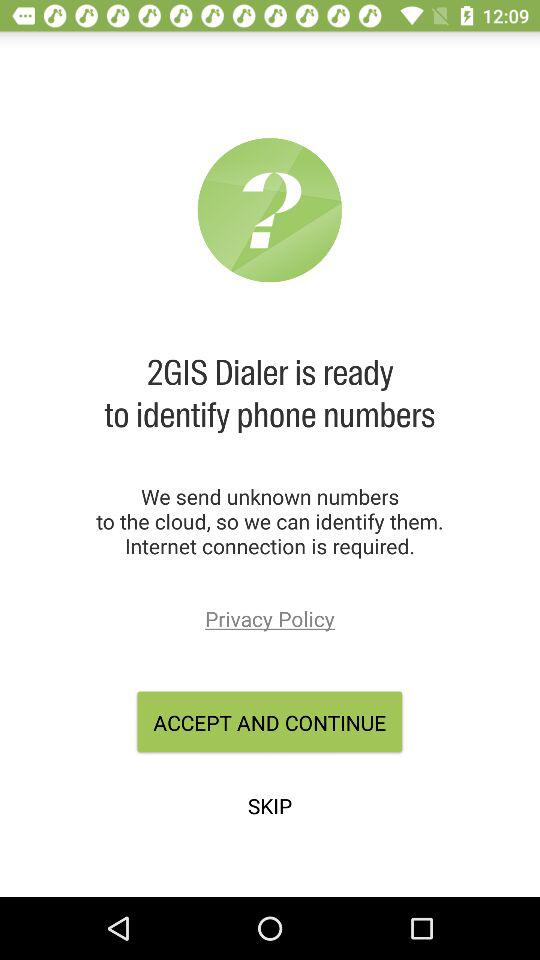Has the user agreed to the privacy policy?
When the provided information is insufficient, respond with <no answer>. <no answer> 